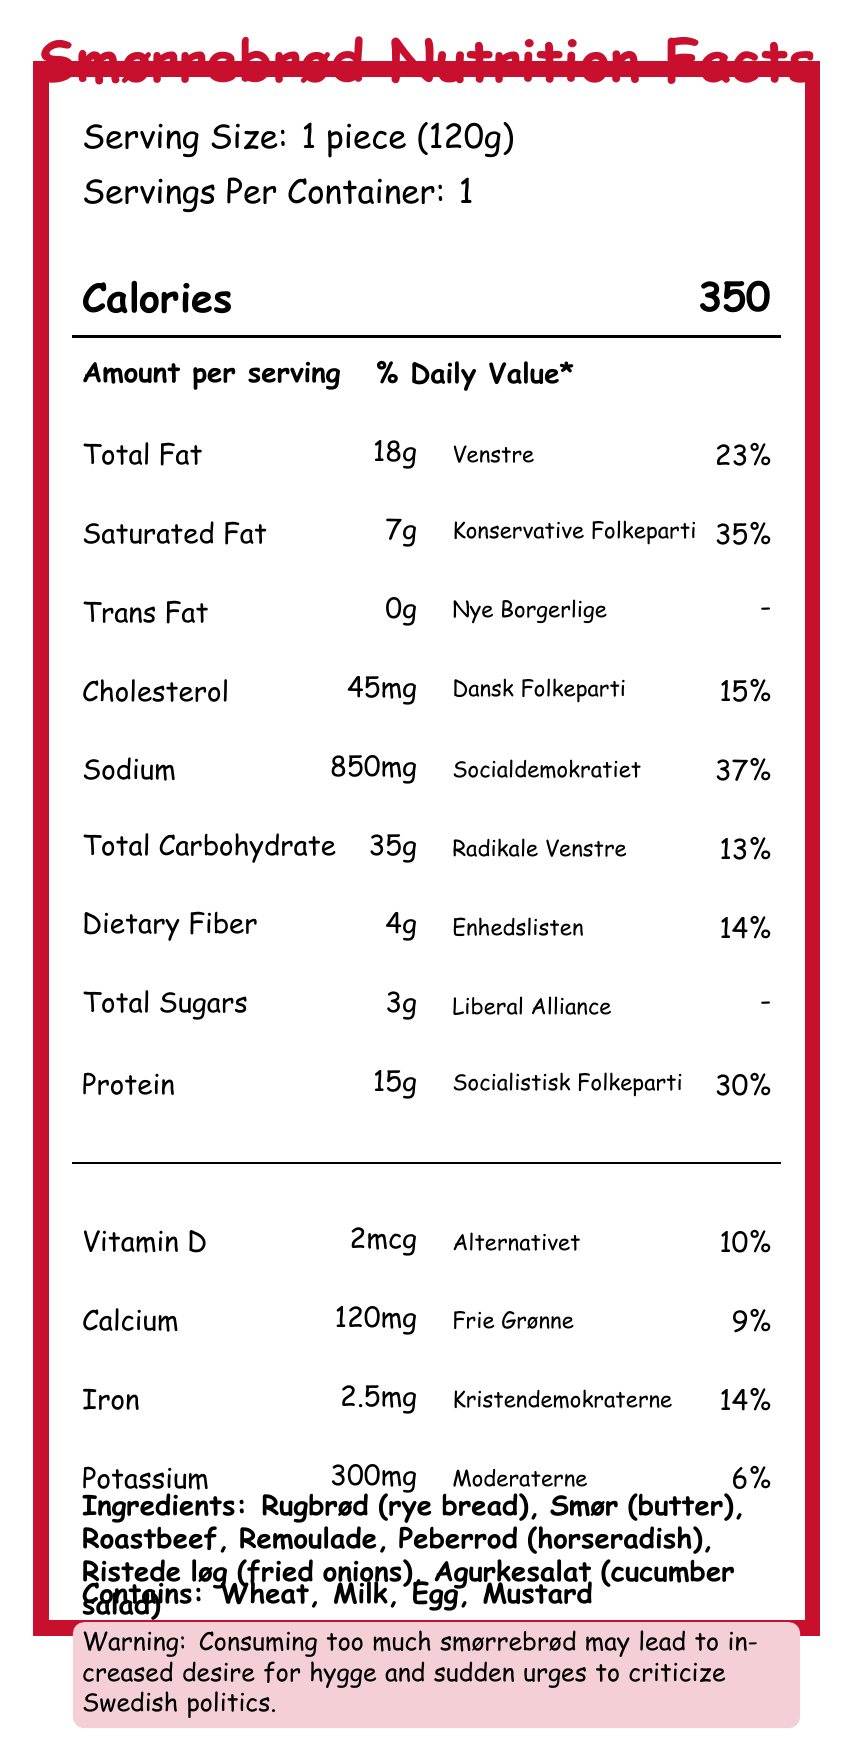what is the serving size for the smørrebrød? The serving size is listed at the top of the document as "Serving Size: 1 piece (120g)".
Answer: 1 piece (120g) how many calories are in one serving of the smørrebrød? The document shows "Calories 350" prominently in the middle of the page.
Answer: 350 which nutrient has the highest % Daily Value? The nutrient Sodium has a % Daily Value of 37%, which is the highest among the listed nutrients.
Answer: Sodium what ingredient may be an allergen for individuals with mustard allergies? The list of allergens at the bottom of the document includes "Mustard".
Answer: Mustard what political party logo represents the Total Fat in the smørrebrød? The Total Fat is represented by the party logo "Venstre".
Answer: Venstre what is the % Daily Value of Protein? A. 14% B. 23% C. 30% D. 37% The document indicates that the % Daily Value of Protein is 30%.
Answer: C. 30% which ingredient is not listed in the smørrebrød? A. Rye bread B. Salmon C. Horseradish D. Butter The list of ingredients includes "Rugbrød (rye bread), Smør (butter), Roastbeef, Remoulade, Peberrod (horseradish), Ristede løg (fried onions), Agurkesalat (cucumber salad)", but not salmon.
Answer: B. Salmon does the smørrebrød contain any trans fat? The document shows that Trans Fat is 0g.
Answer: No summarize the main idea of the document. The document merges nutrition information with a playful exploration of Danish political parties, presenting a smørrebrød's nutritional content in a visually engaging manner.
Answer: The document provides the Nutrition Facts for a traditional Danish smørrebrød, linking each nutrient to a Danish political party logo. It includes serving size, calories, primary nutrients (with % Daily Values), vitamins and minerals, ingredients, allergens, and a humorous political joke. which political party represents the nutrient with the highest amount per serving? Sodium, represented by Socialdemokratiet, has the highest amount per serving (850mg).
Answer: Socialdemokratiet what is the total amount of vitamin D in the smørrebrød? The document lists the amount of Vitamin D as 2mcg.
Answer: 2mcg what % Daily Value does Iron provide in the smørrebrød? The % Daily Value for Iron is indicated as 14%.
Answer: 14% which party icon is shown for Dietary Fiber? Dietary Fiber is represented by the Enhedslisten political party logo.
Answer: Enhedslisten could this smørrebrød potentially be a good source of protein? Why or why not? The document shows that one serving of the smørrebrød provides 15g of Protein, which is 30% of the Daily Value, indicating it is a substantial source of protein.
Answer: Yes, it contains 30% of the Daily Value for Protein. which nutrient does not have a % Daily Value listed? The % Daily Value for Trans Fat is not provided in the document.
Answer: Trans Fat does this smørrebrød have any dietary fiber? If so, what amount? The document shows that the smørrebrød has 4g of Dietary Fiber.
Answer: Yes, 4g how many jokes related to Danish political context are included in this document? There is only one political joke listed near the bottom of the document, stating: "Warning: Consuming too much smørrebrød may lead to increased desire for hygge and sudden urges to criticize Swedish politics."
Answer: One why might the use of political party logos be significant in this document? The document draws a parallel between the variety of smørrebrød toppings and the Danish political spectrum, suggesting a theme of coalition-building and compromise.
Answer: It symbolizes the diverse political landscape of Denmark, similar to the variety of toppings on smørrebrød. what is the exact amount of calories from fat? The document only lists the Total Fat content as 18g but does not provide specific information on calories from fat.
Answer: Cannot be determined 